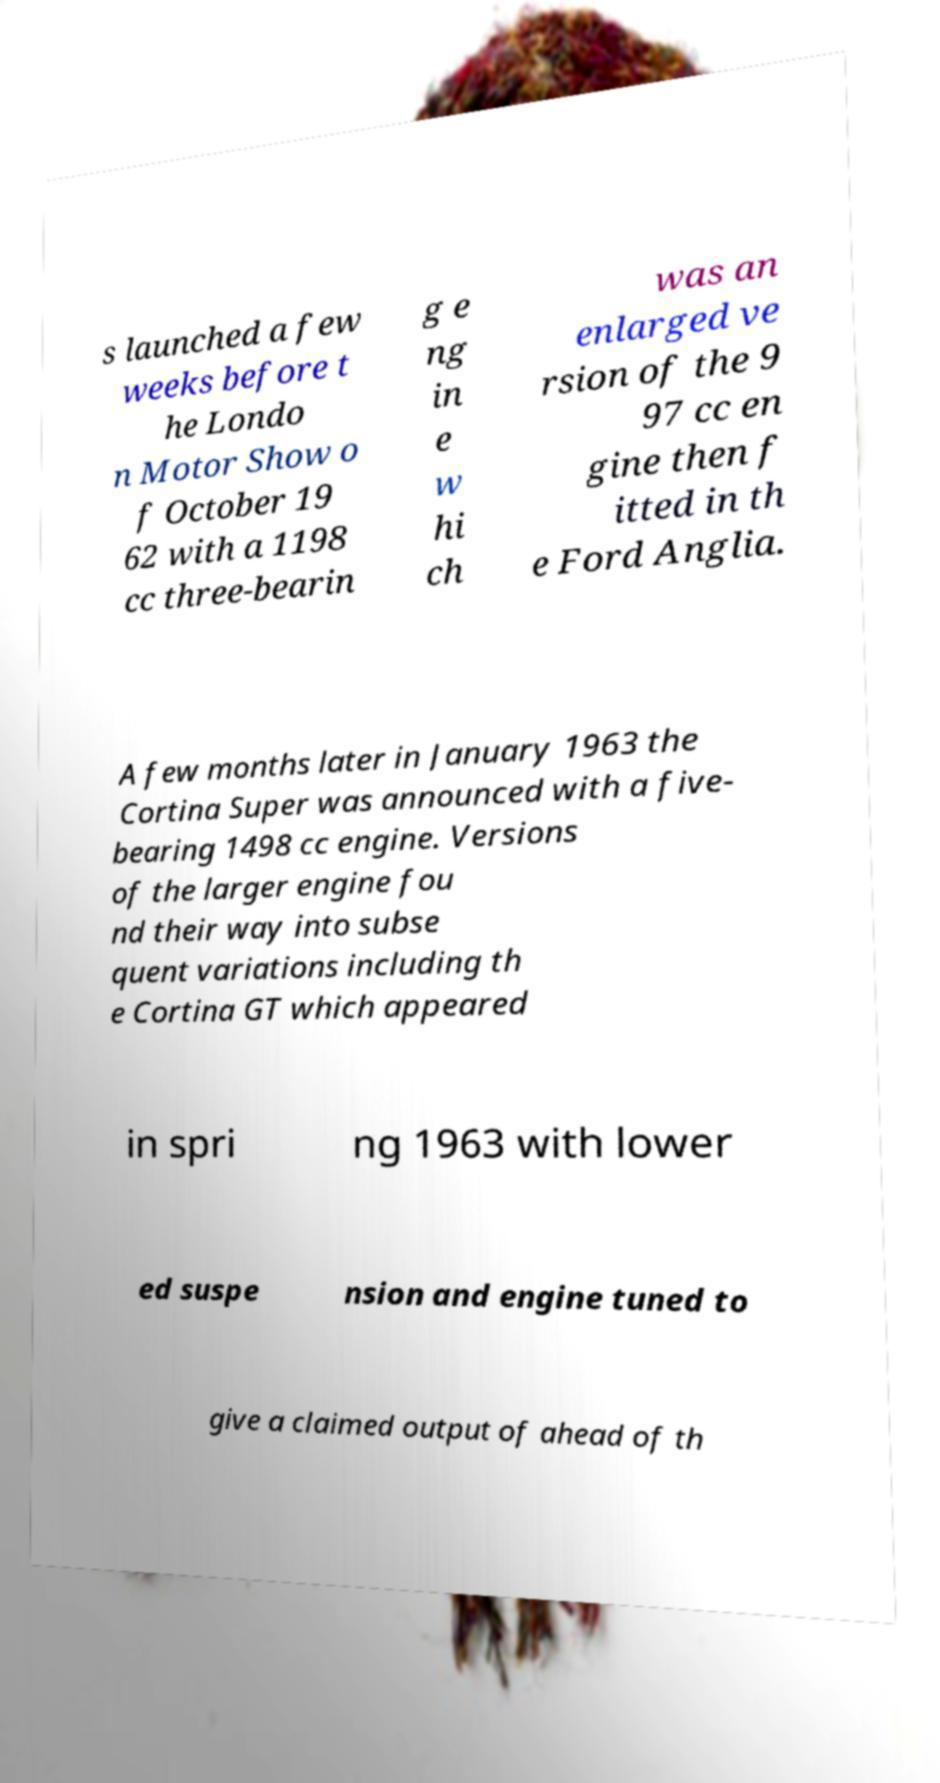Could you extract and type out the text from this image? s launched a few weeks before t he Londo n Motor Show o f October 19 62 with a 1198 cc three-bearin g e ng in e w hi ch was an enlarged ve rsion of the 9 97 cc en gine then f itted in th e Ford Anglia. A few months later in January 1963 the Cortina Super was announced with a five- bearing 1498 cc engine. Versions of the larger engine fou nd their way into subse quent variations including th e Cortina GT which appeared in spri ng 1963 with lower ed suspe nsion and engine tuned to give a claimed output of ahead of th 